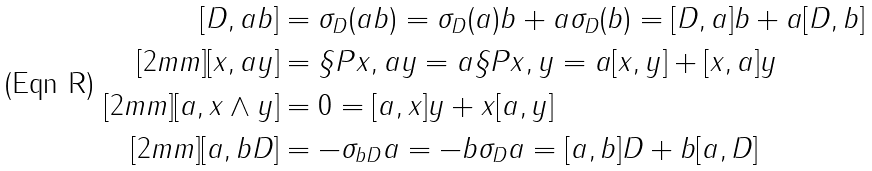Convert formula to latex. <formula><loc_0><loc_0><loc_500><loc_500>[ D , a b ] & = \sigma _ { D } ( a b ) = \sigma _ { D } ( a ) b + a \sigma _ { D } ( b ) = [ D , a ] b + a [ D , b ] \\ [ 2 m m ] [ x , a y ] & = \S P { x , a y } = a \S P { x , y } = a [ x , y ] + [ x , a ] y \\ [ 2 m m ] [ a , x \wedge y ] & = 0 = [ a , x ] y + x [ a , y ] \\ [ 2 m m ] [ a , b D ] & = - \sigma _ { b D } a = - b \sigma _ { D } a = [ a , b ] D + b [ a , D ]</formula> 